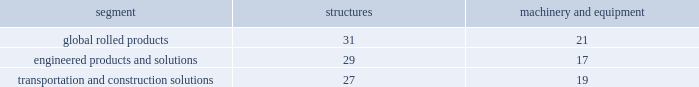Properties , plants , and equipment .
Properties , plants , and equipment are recorded at cost .
Depreciation is recorded principally on the straight-line method at rates based on the estimated useful lives of the assets .
The table details the weighted-average useful lives of structures and machinery and equipment by reporting segment ( numbers in years ) : .
Gains or losses from the sale of assets are generally recorded in other income , net ( see policy below for assets classified as held for sale and discontinued operations ) .
Repairs and maintenance are charged to expense as incurred .
Interest related to the construction of qualifying assets is capitalized as part of the construction costs .
Properties , plants , and equipment are reviewed for impairment whenever events or changes in circumstances indicate that the carrying amount of such assets ( asset group ) may not be recoverable .
Recoverability of assets is determined by comparing the estimated undiscounted net cash flows of the operations related to the assets ( asset group ) to their carrying amount .
An impairment loss would be recognized when the carrying amount of the assets ( asset group ) exceeds the estimated undiscounted net cash flows .
The amount of the impairment loss to be recorded is calculated as the excess of the carrying value of the assets ( asset group ) over their fair value , with fair value determined using the best information available , which generally is a discounted cash flow ( dcf ) model .
The determination of what constitutes an asset group , the associated estimated undiscounted net cash flows , and the estimated useful lives of assets also require significant judgments .
Goodwill and other intangible assets .
Goodwill is not amortized ; instead , it is reviewed for impairment annually ( in the fourth quarter ) or more frequently if indicators of impairment exist or if a decision is made to sell or exit a business .
A significant amount of judgment is involved in determining if an indicator of impairment has occurred .
Such indicators may include deterioration in general economic conditions , negative developments in equity and credit markets , adverse changes in the markets in which an entity operates , increases in input costs that have a negative effect on earnings and cash flows , or a trend of negative or declining cash flows over multiple periods , among others .
The fair value that could be realized in an actual transaction may differ from that used to evaluate the impairment of goodwill .
Goodwill is allocated among and evaluated for impairment at the reporting unit level , which is defined as an operating segment or one level below an operating segment .
Arconic has eight reporting units , of which four are included in the engineered products and solutions segment , three are included in the transportation and construction solutions segment , and the remaining reporting unit is the global rolled products segment .
More than 70% ( 70 % ) of arconic 2019s total goodwill is allocated to two reporting units as follows : arconic fastening systems and rings ( afsr ) ( $ 2200 ) and arconic power and propulsion ( app ) ( $ 1647 ) businesses , both of which are included in the engineered products and solutions segment .
These amounts include an allocation of corporate 2019s goodwill .
In november 2014 , arconic acquired firth rixson ( see note f ) , and , as a result recognized $ 1801 in goodwill .
This amount was allocated between the afsr and arconic forgings and extrusions ( afe ) reporting units , which is part of the engineered products and solutions segment .
In march and july 2015 , arconic acquired tital and rti , respectively , ( see note f ) and recognized $ 117 and $ 298 , respectively , in goodwill .
The goodwill amount related to tital was allocated to the app reporting unit and the amount related to rti was allocated to arconic titanium and engineered products ( atep ) , a new arconic reporting unit that consists solely of the acquired rti business and is part of the engineered products and solutions segment .
In reviewing goodwill for impairment , an entity has the option to first assess qualitative factors to determine whether the existence of events or circumstances leads to a determination that it is more likely than not ( greater than 50% ( 50 % ) ) that the estimated fair value of a reporting unit is less than its carrying amount .
If an entity elects to perform a qualitative assessment and determines that an impairment is more likely than not , the entity is then required to perform the .
What is the difference between firth rixson's goodwill and the rti's? 
Rationale: it is the variation between each company's goodwill .
Computations: (1801 - 298)
Answer: 1503.0. Properties , plants , and equipment .
Properties , plants , and equipment are recorded at cost .
Depreciation is recorded principally on the straight-line method at rates based on the estimated useful lives of the assets .
The table details the weighted-average useful lives of structures and machinery and equipment by reporting segment ( numbers in years ) : .
Gains or losses from the sale of assets are generally recorded in other income , net ( see policy below for assets classified as held for sale and discontinued operations ) .
Repairs and maintenance are charged to expense as incurred .
Interest related to the construction of qualifying assets is capitalized as part of the construction costs .
Properties , plants , and equipment are reviewed for impairment whenever events or changes in circumstances indicate that the carrying amount of such assets ( asset group ) may not be recoverable .
Recoverability of assets is determined by comparing the estimated undiscounted net cash flows of the operations related to the assets ( asset group ) to their carrying amount .
An impairment loss would be recognized when the carrying amount of the assets ( asset group ) exceeds the estimated undiscounted net cash flows .
The amount of the impairment loss to be recorded is calculated as the excess of the carrying value of the assets ( asset group ) over their fair value , with fair value determined using the best information available , which generally is a discounted cash flow ( dcf ) model .
The determination of what constitutes an asset group , the associated estimated undiscounted net cash flows , and the estimated useful lives of assets also require significant judgments .
Goodwill and other intangible assets .
Goodwill is not amortized ; instead , it is reviewed for impairment annually ( in the fourth quarter ) or more frequently if indicators of impairment exist or if a decision is made to sell or exit a business .
A significant amount of judgment is involved in determining if an indicator of impairment has occurred .
Such indicators may include deterioration in general economic conditions , negative developments in equity and credit markets , adverse changes in the markets in which an entity operates , increases in input costs that have a negative effect on earnings and cash flows , or a trend of negative or declining cash flows over multiple periods , among others .
The fair value that could be realized in an actual transaction may differ from that used to evaluate the impairment of goodwill .
Goodwill is allocated among and evaluated for impairment at the reporting unit level , which is defined as an operating segment or one level below an operating segment .
Arconic has eight reporting units , of which four are included in the engineered products and solutions segment , three are included in the transportation and construction solutions segment , and the remaining reporting unit is the global rolled products segment .
More than 70% ( 70 % ) of arconic 2019s total goodwill is allocated to two reporting units as follows : arconic fastening systems and rings ( afsr ) ( $ 2200 ) and arconic power and propulsion ( app ) ( $ 1647 ) businesses , both of which are included in the engineered products and solutions segment .
These amounts include an allocation of corporate 2019s goodwill .
In november 2014 , arconic acquired firth rixson ( see note f ) , and , as a result recognized $ 1801 in goodwill .
This amount was allocated between the afsr and arconic forgings and extrusions ( afe ) reporting units , which is part of the engineered products and solutions segment .
In march and july 2015 , arconic acquired tital and rti , respectively , ( see note f ) and recognized $ 117 and $ 298 , respectively , in goodwill .
The goodwill amount related to tital was allocated to the app reporting unit and the amount related to rti was allocated to arconic titanium and engineered products ( atep ) , a new arconic reporting unit that consists solely of the acquired rti business and is part of the engineered products and solutions segment .
In reviewing goodwill for impairment , an entity has the option to first assess qualitative factors to determine whether the existence of events or circumstances leads to a determination that it is more likely than not ( greater than 50% ( 50 % ) ) that the estimated fair value of a reporting unit is less than its carrying amount .
If an entity elects to perform a qualitative assessment and determines that an impairment is more likely than not , the entity is then required to perform the .
What is the total goodwill of arconic , in dollars? 
Rationale: the total 100% of arconic's goodwill is calculated based on the facts that the sum of arconic fastening systems and rings ( $ 2200 ) and arconic power and propulsion ( $ 1647 ) totalizes 70% of the total .
Computations: (((2200 + 1647) * 100) / 70)
Answer: 5495.71429. 